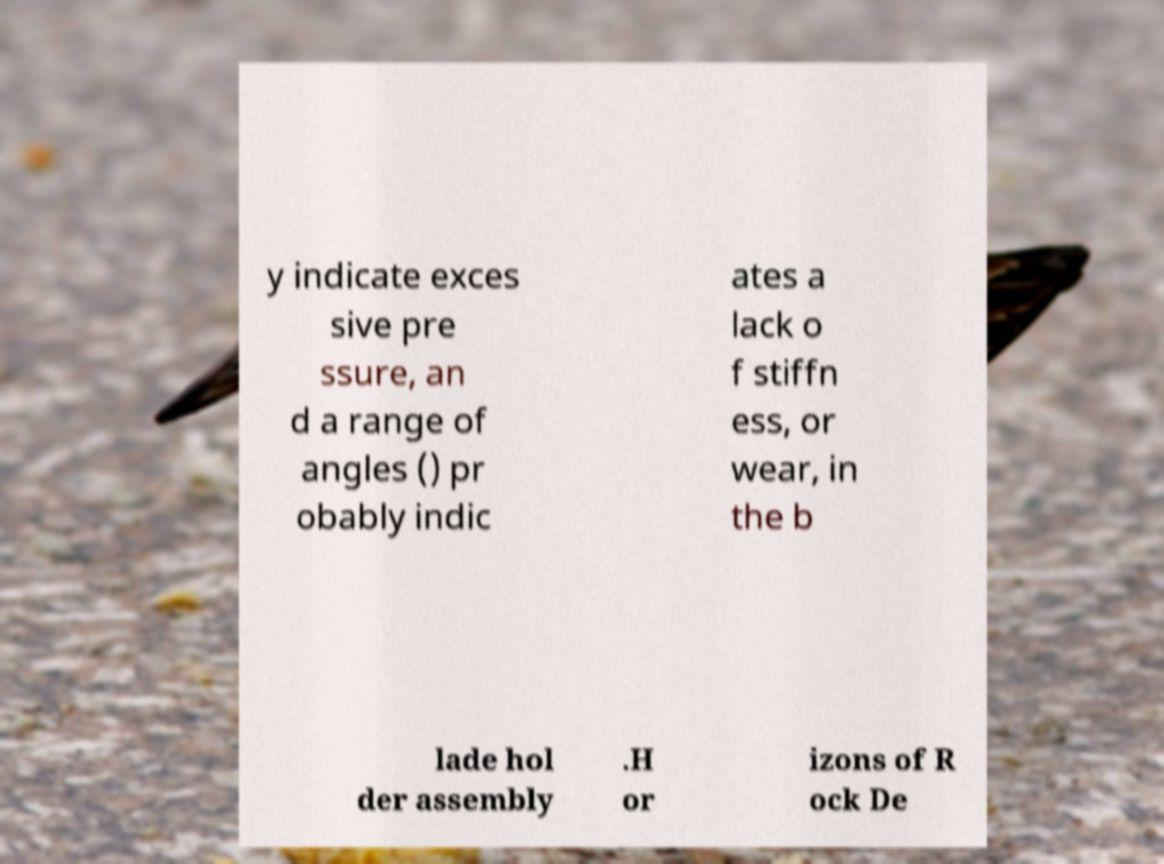Could you assist in decoding the text presented in this image and type it out clearly? y indicate exces sive pre ssure, an d a range of angles () pr obably indic ates a lack o f stiffn ess, or wear, in the b lade hol der assembly .H or izons of R ock De 